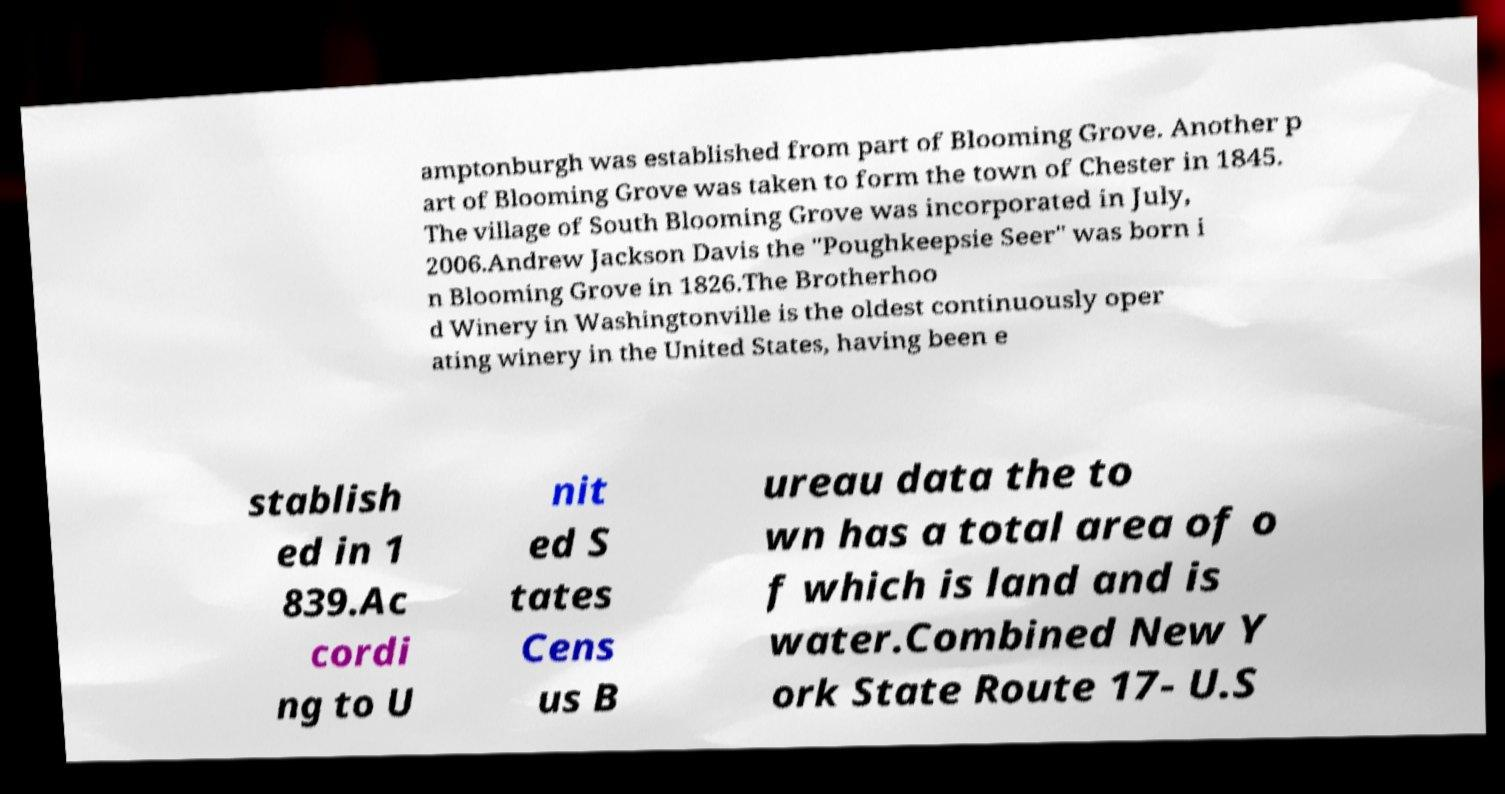I need the written content from this picture converted into text. Can you do that? amptonburgh was established from part of Blooming Grove. Another p art of Blooming Grove was taken to form the town of Chester in 1845. The village of South Blooming Grove was incorporated in July, 2006.Andrew Jackson Davis the "Poughkeepsie Seer" was born i n Blooming Grove in 1826.The Brotherhoo d Winery in Washingtonville is the oldest continuously oper ating winery in the United States, having been e stablish ed in 1 839.Ac cordi ng to U nit ed S tates Cens us B ureau data the to wn has a total area of o f which is land and is water.Combined New Y ork State Route 17- U.S 